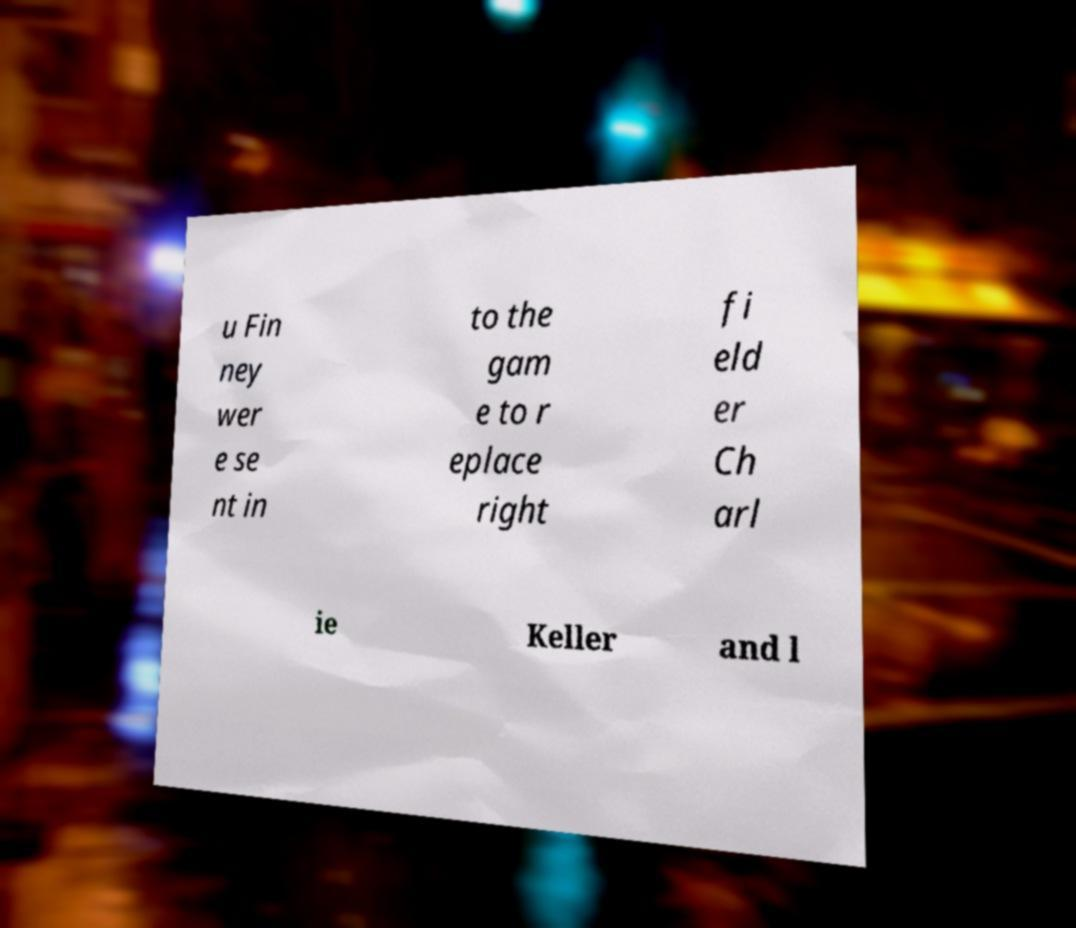Can you read and provide the text displayed in the image?This photo seems to have some interesting text. Can you extract and type it out for me? u Fin ney wer e se nt in to the gam e to r eplace right fi eld er Ch arl ie Keller and l 